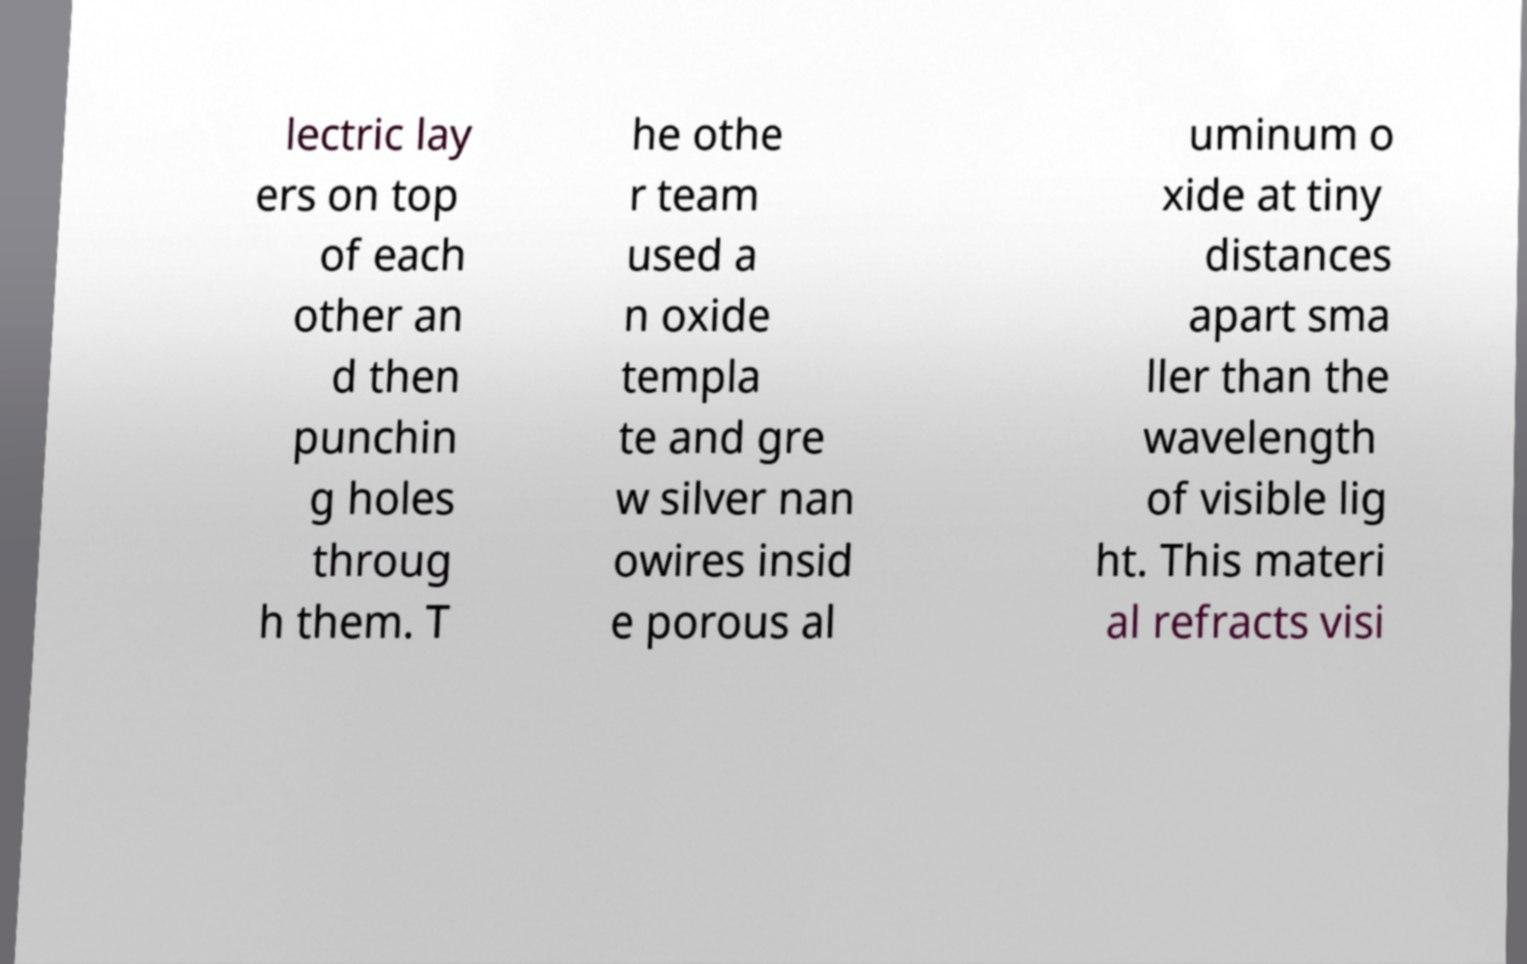Could you assist in decoding the text presented in this image and type it out clearly? lectric lay ers on top of each other an d then punchin g holes throug h them. T he othe r team used a n oxide templa te and gre w silver nan owires insid e porous al uminum o xide at tiny distances apart sma ller than the wavelength of visible lig ht. This materi al refracts visi 